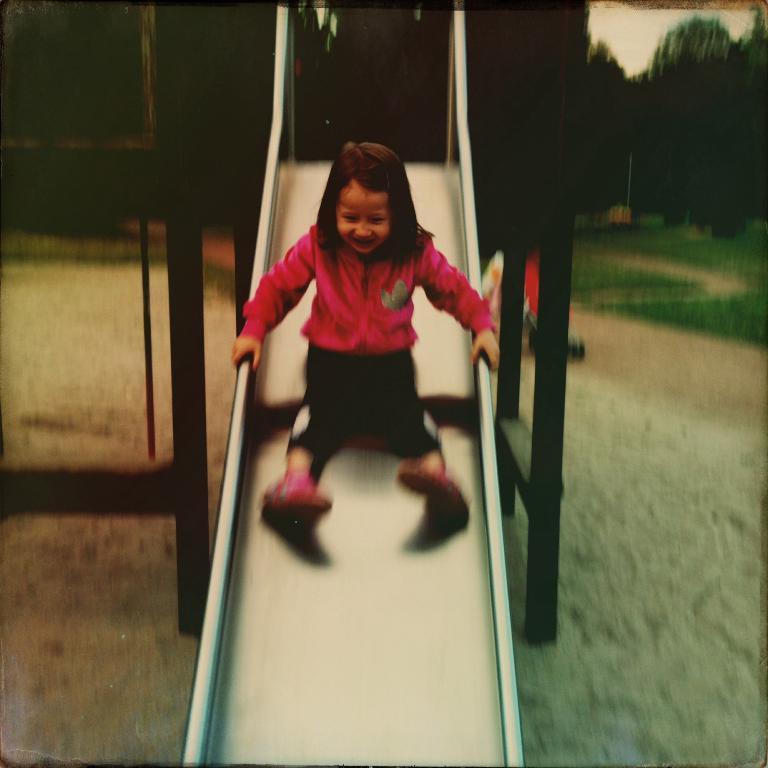Please provide a concise description of this image. In this image we can see a child is sliding on the garden slide. The background of the image is blurred, where we can see trees. 